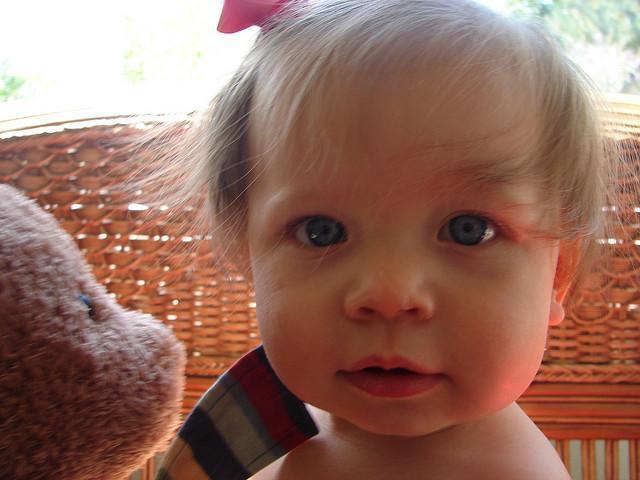Verify the accuracy of this image caption: "The teddy bear is facing the person.".
Answer yes or no. Yes. 